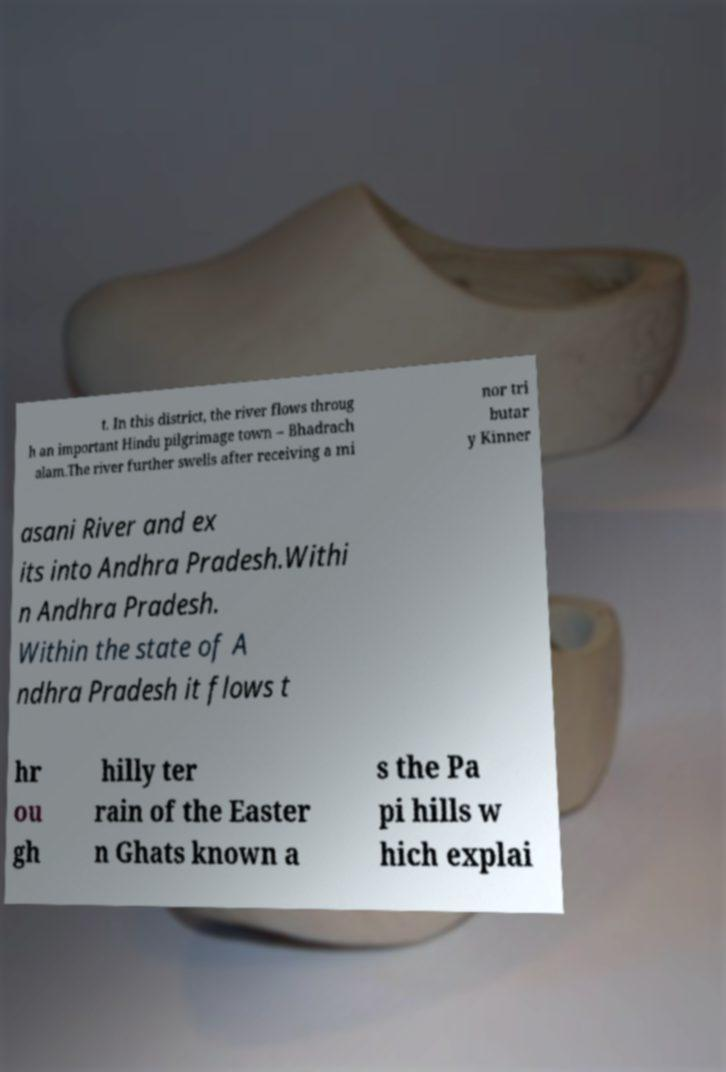Can you read and provide the text displayed in the image?This photo seems to have some interesting text. Can you extract and type it out for me? t. In this district, the river flows throug h an important Hindu pilgrimage town – Bhadrach alam.The river further swells after receiving a mi nor tri butar y Kinner asani River and ex its into Andhra Pradesh.Withi n Andhra Pradesh. Within the state of A ndhra Pradesh it flows t hr ou gh hilly ter rain of the Easter n Ghats known a s the Pa pi hills w hich explai 